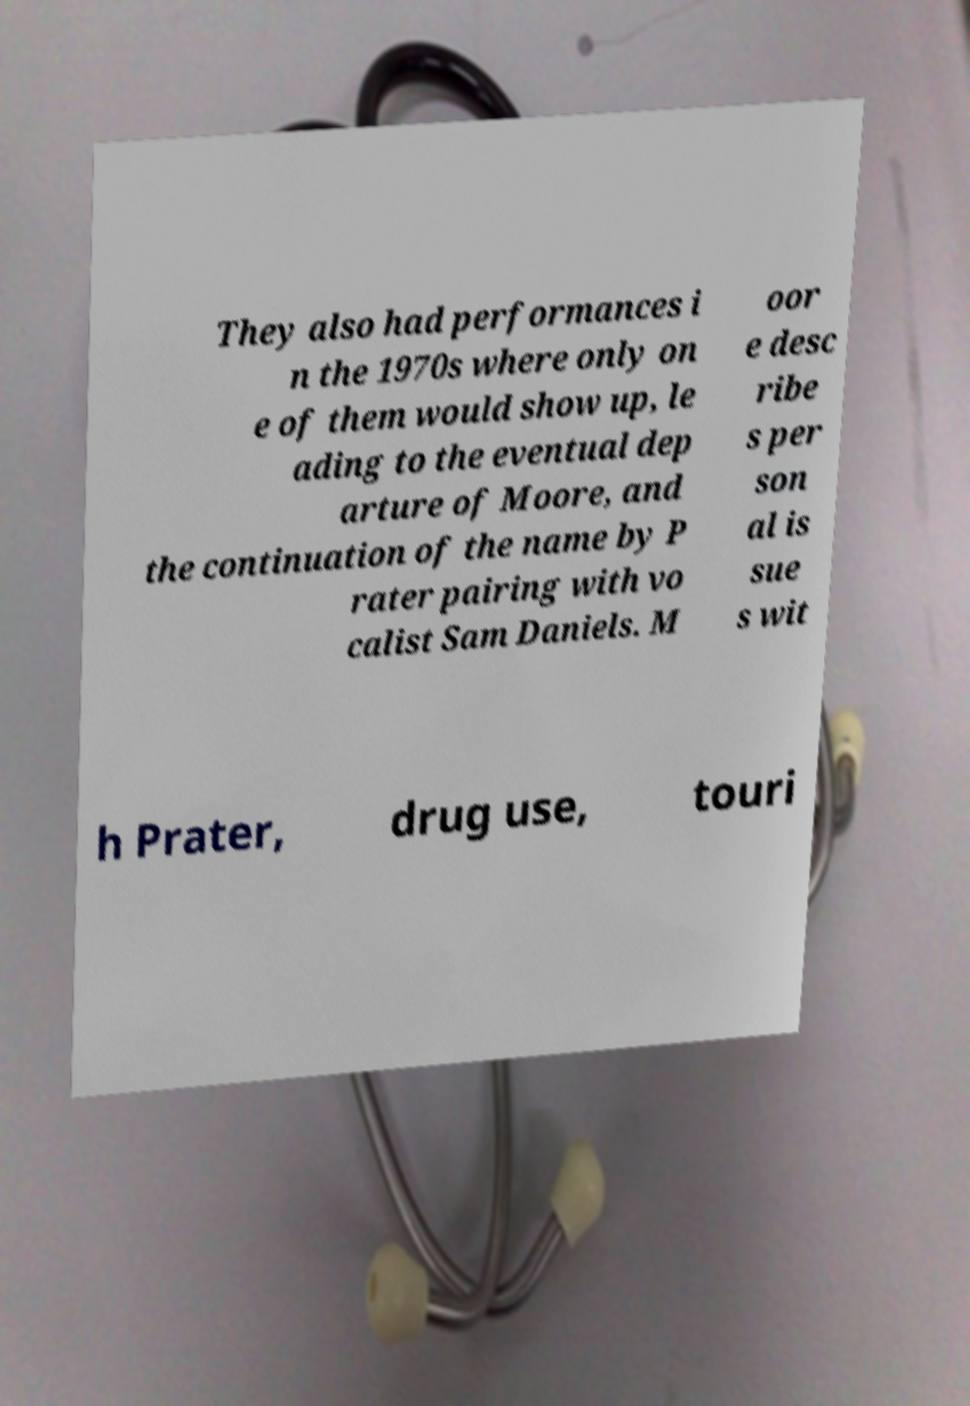For documentation purposes, I need the text within this image transcribed. Could you provide that? They also had performances i n the 1970s where only on e of them would show up, le ading to the eventual dep arture of Moore, and the continuation of the name by P rater pairing with vo calist Sam Daniels. M oor e desc ribe s per son al is sue s wit h Prater, drug use, touri 